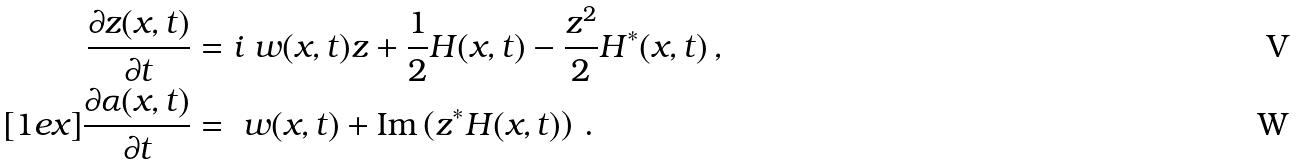<formula> <loc_0><loc_0><loc_500><loc_500>\frac { \partial z ( x , t ) } { \partial t } & = i \ w ( x , t ) z + \frac { 1 } { 2 } H ( x , t ) - \frac { z ^ { 2 } } { 2 } H ^ { * } ( x , t ) \, , \\ [ 1 e x ] \frac { \partial \alpha ( x , t ) } { \partial t } & = \ w ( x , t ) + \text {Im} \left ( z ^ { * } H ( x , t ) \right ) \, .</formula> 